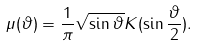<formula> <loc_0><loc_0><loc_500><loc_500>\mu ( \vartheta ) = \frac { 1 } { \pi } \sqrt { \sin \vartheta } K ( \sin \frac { \vartheta } { 2 } ) .</formula> 